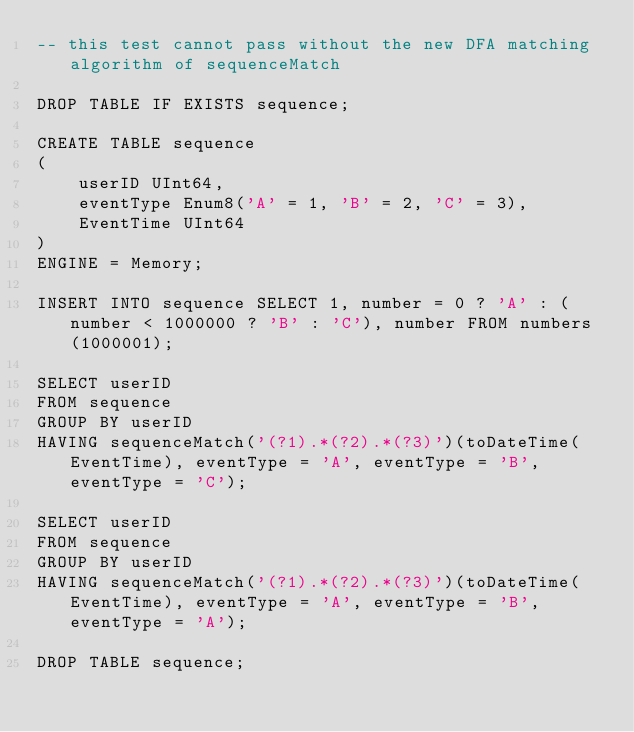<code> <loc_0><loc_0><loc_500><loc_500><_SQL_>-- this test cannot pass without the new DFA matching algorithm of sequenceMatch

DROP TABLE IF EXISTS sequence;

CREATE TABLE sequence
(
    userID UInt64,
    eventType Enum8('A' = 1, 'B' = 2, 'C' = 3),
    EventTime UInt64
)
ENGINE = Memory;

INSERT INTO sequence SELECT 1, number = 0 ? 'A' : (number < 1000000 ? 'B' : 'C'), number FROM numbers(1000001);

SELECT userID
FROM sequence
GROUP BY userID
HAVING sequenceMatch('(?1).*(?2).*(?3)')(toDateTime(EventTime), eventType = 'A', eventType = 'B', eventType = 'C');

SELECT userID
FROM sequence
GROUP BY userID
HAVING sequenceMatch('(?1).*(?2).*(?3)')(toDateTime(EventTime), eventType = 'A', eventType = 'B', eventType = 'A');

DROP TABLE sequence;
</code> 